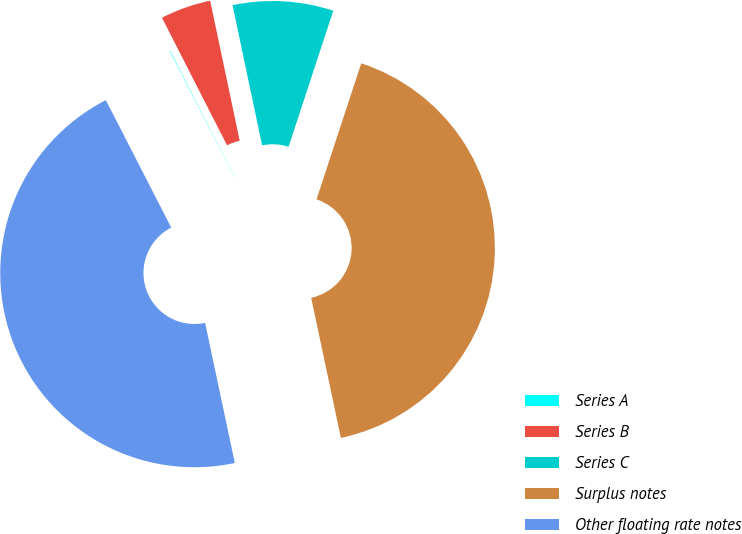<chart> <loc_0><loc_0><loc_500><loc_500><pie_chart><fcel>Series A<fcel>Series B<fcel>Series C<fcel>Surplus notes<fcel>Other floating rate notes<nl><fcel>0.04%<fcel>4.2%<fcel>8.36%<fcel>41.62%<fcel>45.78%<nl></chart> 